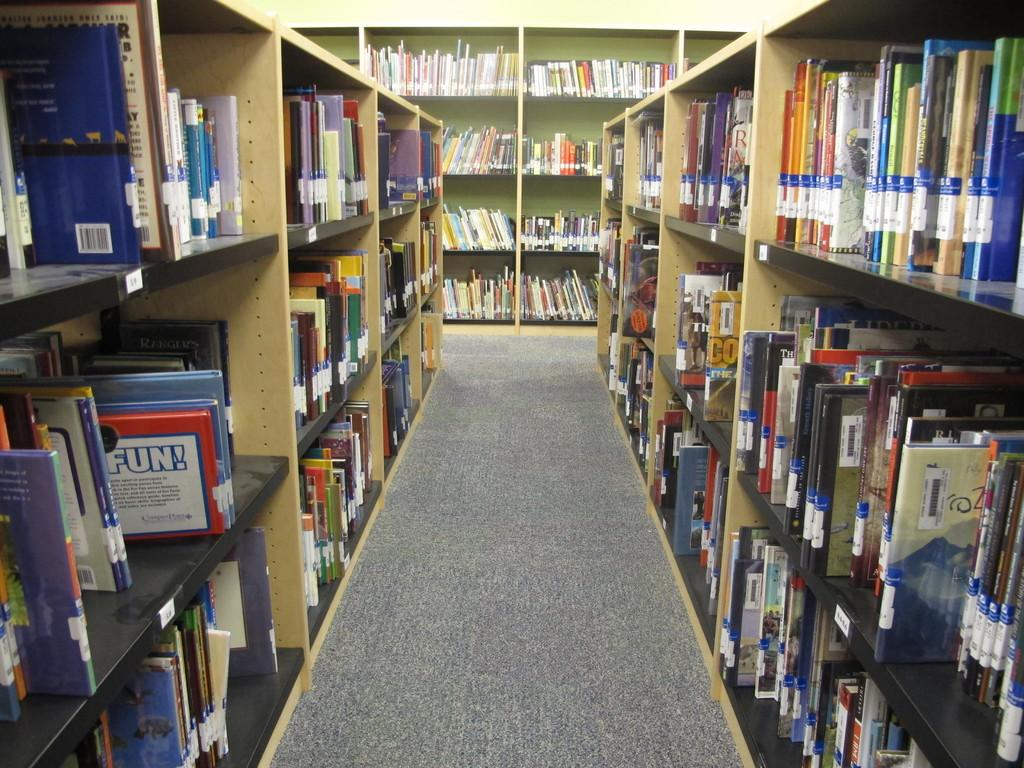What type of surface is visible in the image? The image contains a floor. What items can be seen on the floor in the image? There are no items visible on the floor in the image. What can be seen on the wall in the background of the image? There is no information about the wall in the background of the image. What type of storage is used for the books in the image? The books in the image are stored in racks. What is the taste of the scissors in the image? There are no scissors present in the image, so it is not possible to determine their taste. 